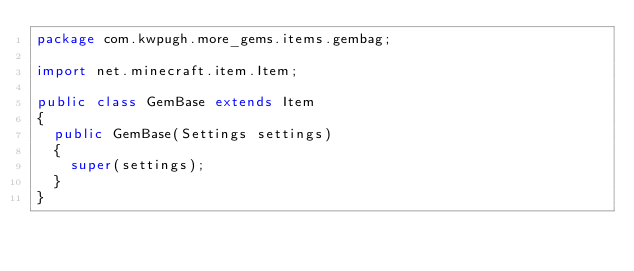Convert code to text. <code><loc_0><loc_0><loc_500><loc_500><_Java_>package com.kwpugh.more_gems.items.gembag;

import net.minecraft.item.Item;

public class GemBase extends Item
{
	public GemBase(Settings settings)
	{
		super(settings);
	}
}
</code> 